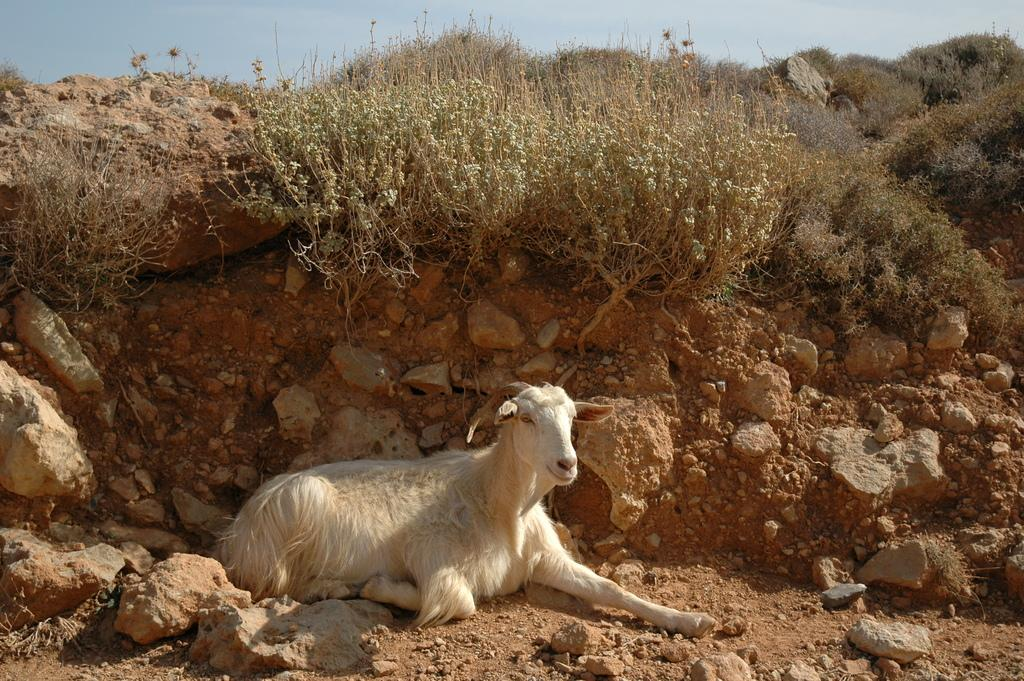What type of animal is in the image? There is a goat in the image. What other living organisms can be seen in the image? There are plants in the image. What type of vegetation is present in the image? There is grass in the image. What type of inanimate objects can be seen in the image? There are rocks in the image. What is visible at the top of the image? The sky is visible at the top of the image. What type of pickle is the goat holding in the image? There is no pickle present in the image; the goat is not holding anything. 